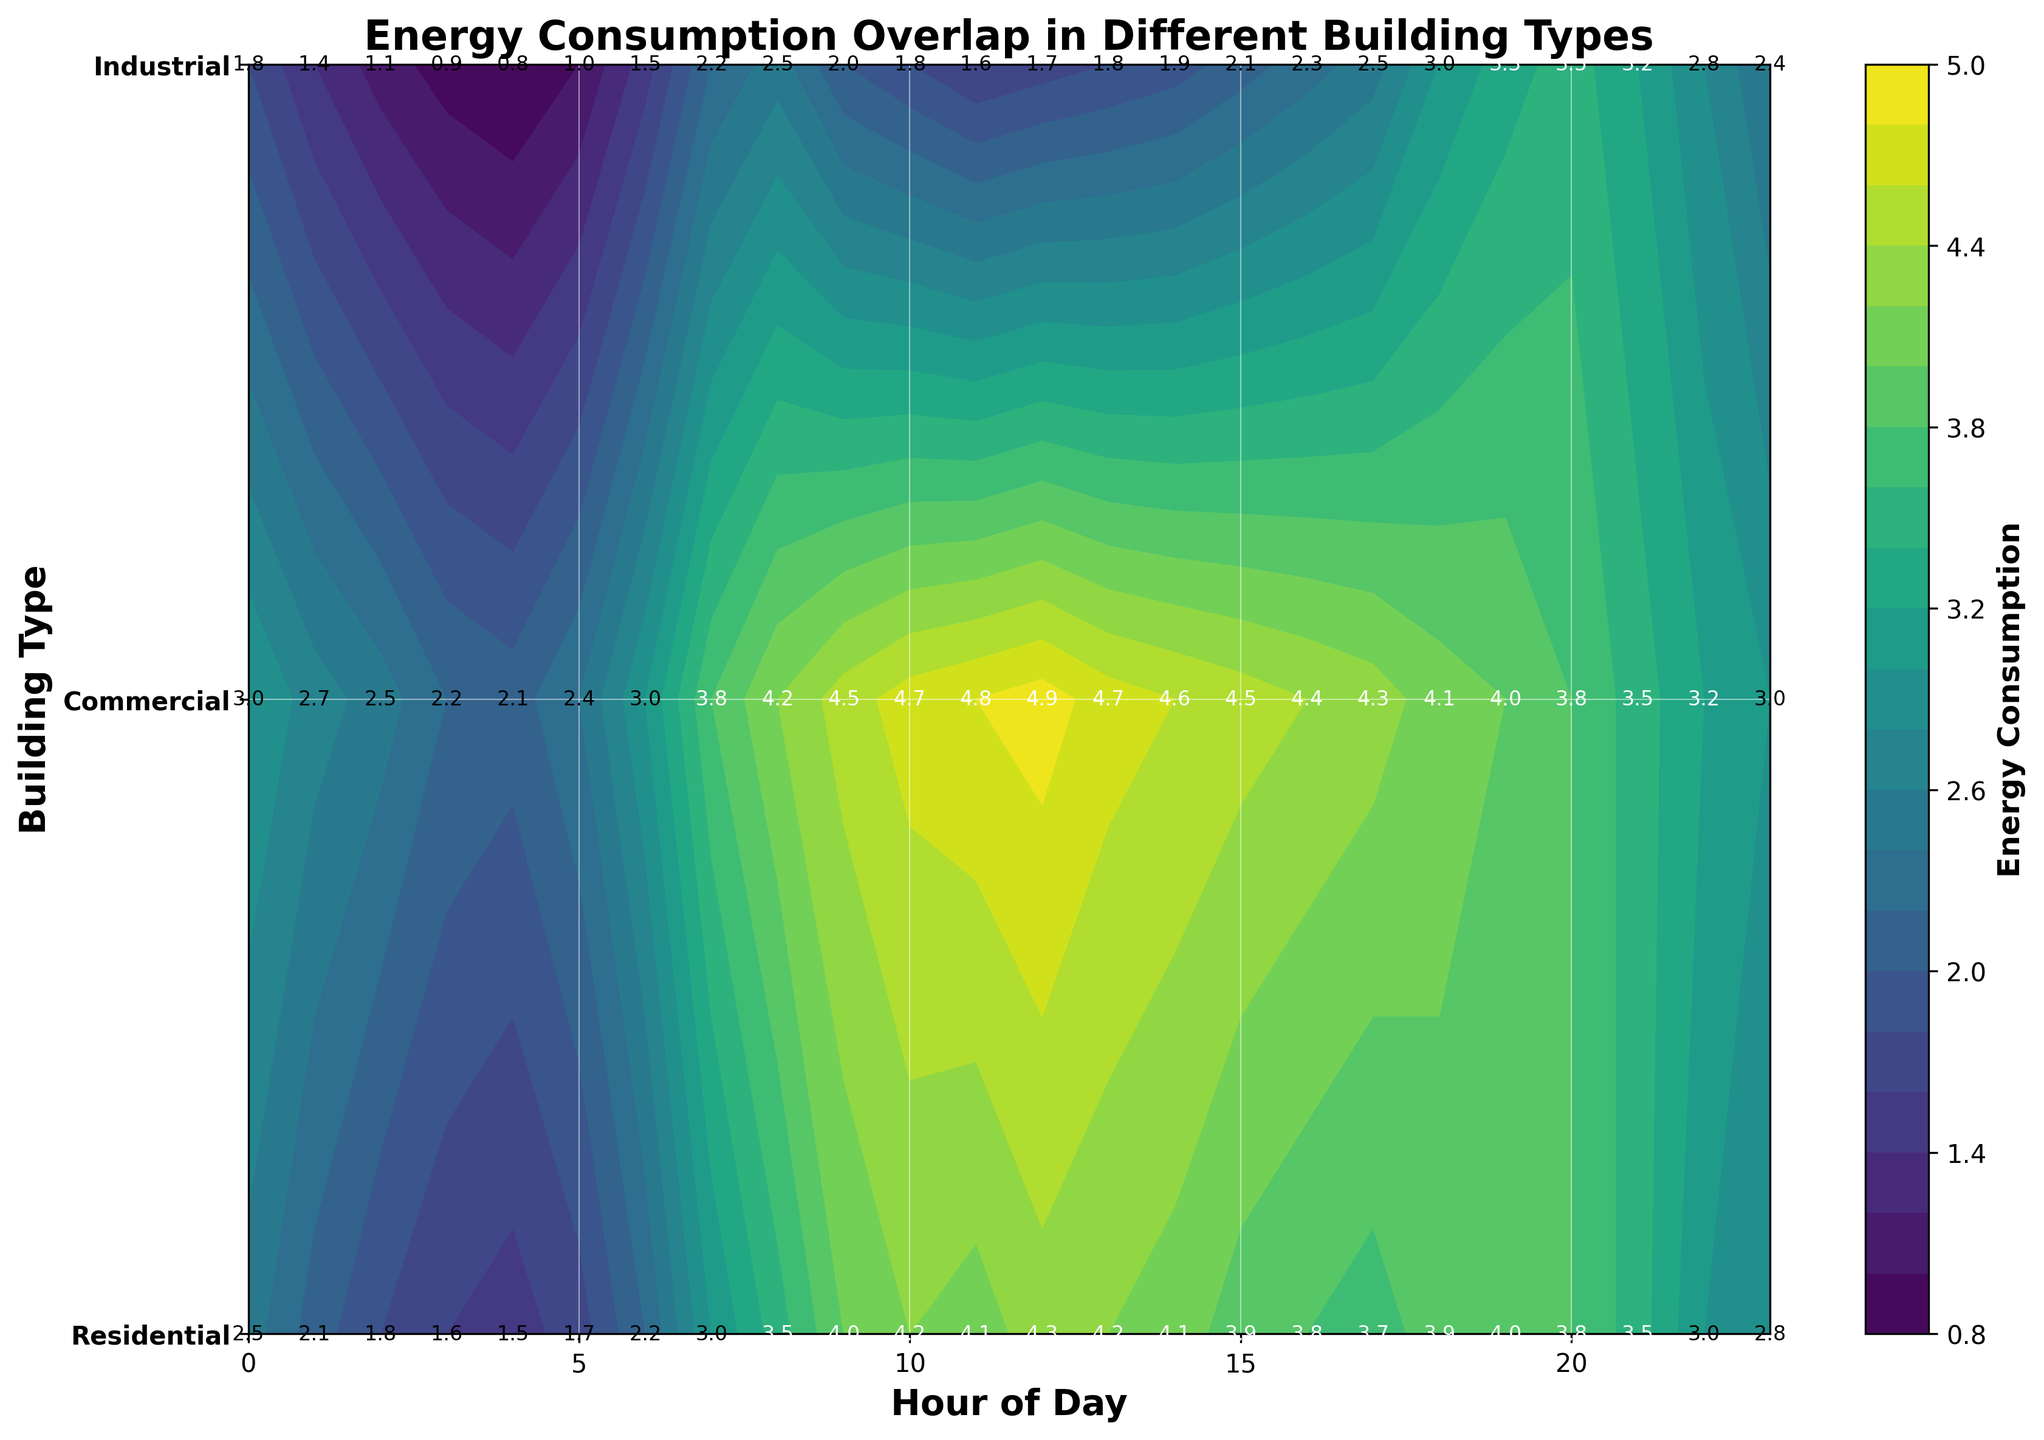What is the title of the plot? The title of the plot is usually located at the top center of the figure. In this case, the title is "Energy Consumption Overlap in Different Building Types".
Answer: Energy Consumption Overlap in Different Building Types What does the colorbar represent? The colorbar in the figure is labeled "Energy Consumption". It indicates the range and intensity of energy consumption values depicted by different colors in the contour plot.
Answer: Energy Consumption Which building type has the highest energy consumption at 12 PM? To determine this, find the values corresponding to 12 PM (Hour 12) for each building type on the contour plot. For Residential, it's 1.7; for Commercial, it's 4.3; and for Industrial, it's 4.9. Therefore, Industrial has the highest energy consumption.
Answer: Industrial At what hour is the energy consumption for Residential buildings the highest? Locate the highest numerical value for Residential on the contour plot. For Residential, the values peak at Hour 20 with a consumption of 3.5.
Answer: 20 Compare the energy consumption at 6 AM between Residential and Commercial buildings. Which one is higher? Check the values at Hour 6 for both Residential and Commercial buildings. For Residential, it's 1.5, and for Commercial, it's 2.2. Therefore, Commercial buildings have higher energy consumption at 6 AM.
Answer: Commercial What is the average energy consumption for Industrial buildings between 9 AM and 12 PM? Sum the energy consumption values for Industrial buildings from 9 AM to 12 PM: 4.5 (9 AM) + 4.7 (10 AM) + 4.8 (11 AM) + 4.9 (12 PM) = 18.9. Divide by the number of hours: 18.9 / 4 = 4.725.
Answer: 4.725 How does the energy consumption trend change for Commercial buildings from 3 PM to 6 PM? For Commercial buildings, check the values at 3 PM (3.9), 4 PM (3.8), 5 PM (3.7), and 6 PM (3.2). The trend decreases from 3.9 to 3.2, indicating a downward trend.
Answer: Decreases Which building type shows the most significant increase in energy consumption during the day? By inspecting the gradient of changes for each building type: Residential shows an increase from 0.8 at 4 AM to 3.5 at 20 PM; Commercial from 1.5 at 4 AM to 4.3 at 12 PM; Industrial from 2.1 at 4 AM to 4.9 at 12 PM. The highest increase is for Industrial buildings.
Answer: Industrial Between which hours does the Commercial building type maintain the highest energy consumption? Look at the values for Commercial. From 9 AM (4.0) to 1 PM (4.2), it maintains peak values ranging between 4.0 and 4.3, which are its highest sustained values.
Answer: 9 AM - 1 PM What is the difference in energy consumption between Industrial and Residential buildings at 8 AM? At 8 AM, Industrial buildings have a consumption of 4.2, while Residential buildings have 2.5. The difference is 4.2 - 2.5 = 1.7.
Answer: 1.7 